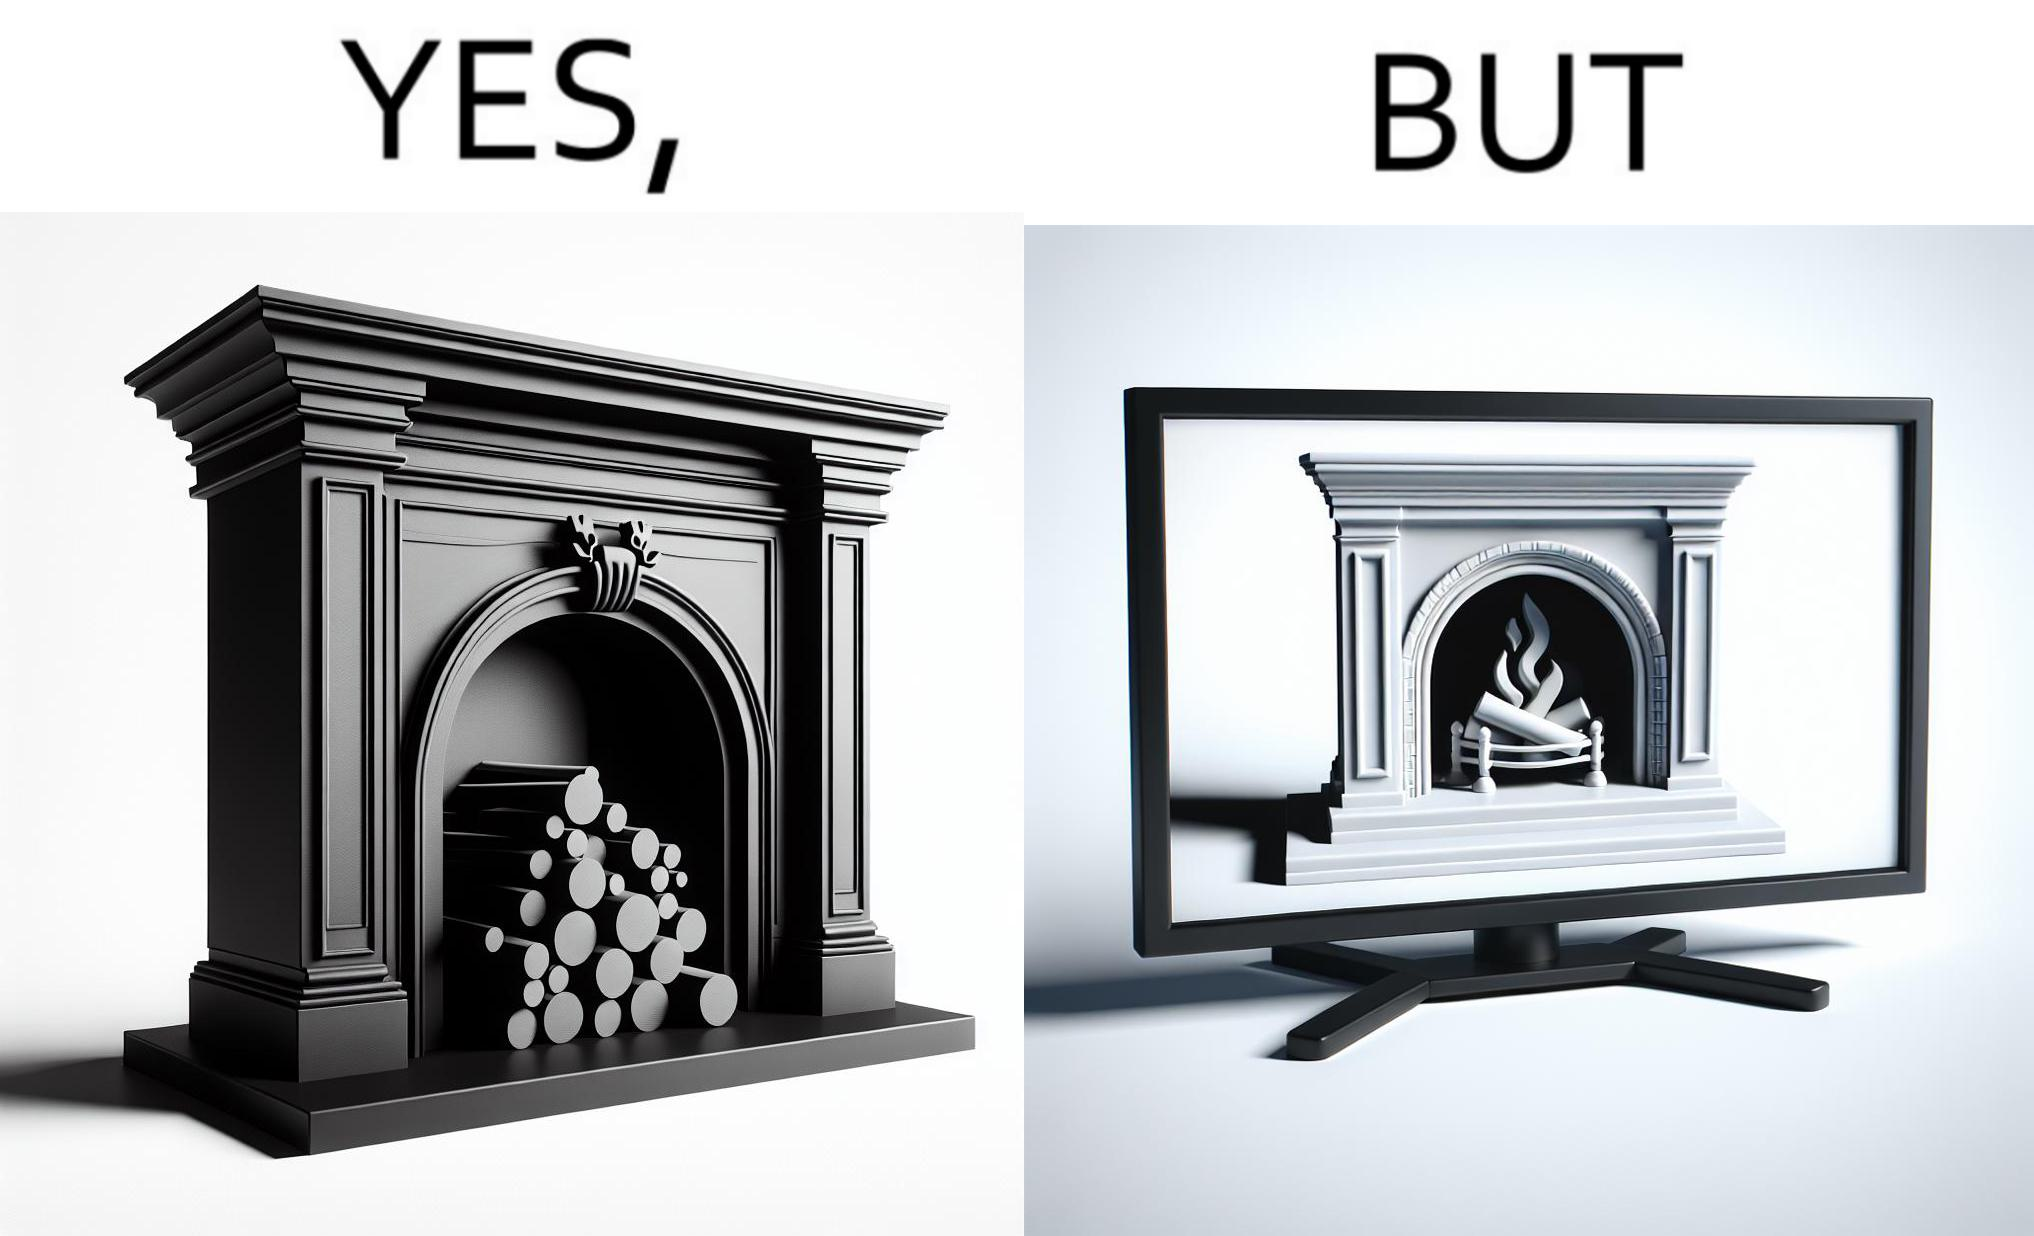What does this image depict? The images are funny since they show how even though real fireplaces exist, people choose to be lazy and watch fireplaces on television because they dont want the inconveniences of cleaning up, etc. afterwards 